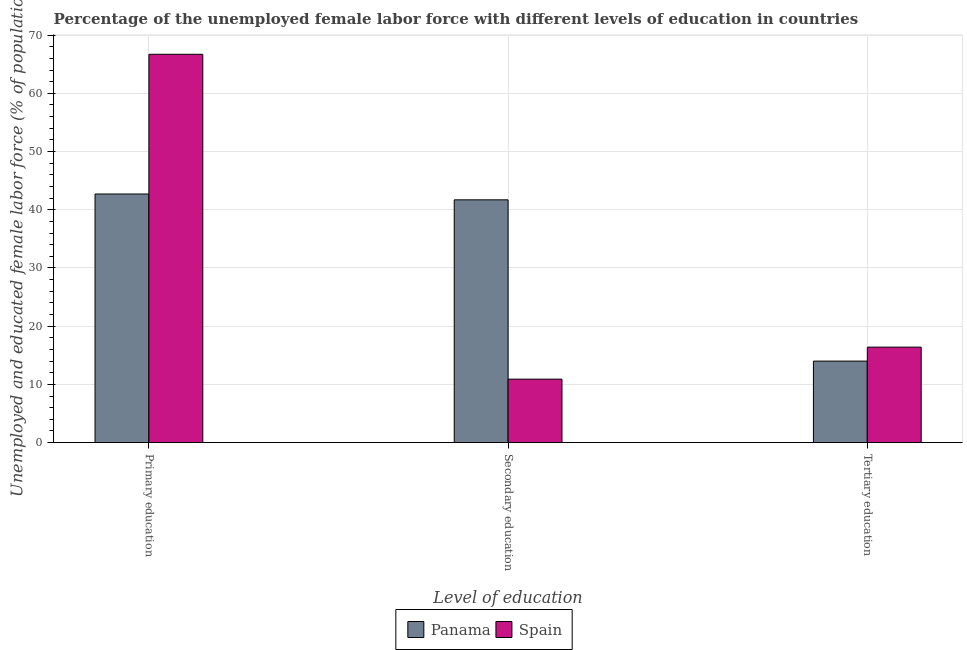How many groups of bars are there?
Provide a succinct answer. 3. Are the number of bars per tick equal to the number of legend labels?
Keep it short and to the point. Yes. Are the number of bars on each tick of the X-axis equal?
Provide a short and direct response. Yes. How many bars are there on the 3rd tick from the left?
Your answer should be compact. 2. How many bars are there on the 3rd tick from the right?
Ensure brevity in your answer.  2. What is the label of the 3rd group of bars from the left?
Ensure brevity in your answer.  Tertiary education. What is the percentage of female labor force who received secondary education in Spain?
Make the answer very short. 10.9. Across all countries, what is the maximum percentage of female labor force who received primary education?
Give a very brief answer. 66.7. In which country was the percentage of female labor force who received secondary education maximum?
Give a very brief answer. Panama. In which country was the percentage of female labor force who received secondary education minimum?
Your response must be concise. Spain. What is the total percentage of female labor force who received primary education in the graph?
Your answer should be compact. 109.4. What is the difference between the percentage of female labor force who received tertiary education in Spain and that in Panama?
Keep it short and to the point. 2.4. What is the difference between the percentage of female labor force who received secondary education in Panama and the percentage of female labor force who received tertiary education in Spain?
Provide a short and direct response. 25.3. What is the average percentage of female labor force who received primary education per country?
Keep it short and to the point. 54.7. What is the difference between the percentage of female labor force who received secondary education and percentage of female labor force who received primary education in Spain?
Your answer should be very brief. -55.8. What is the ratio of the percentage of female labor force who received tertiary education in Panama to that in Spain?
Your answer should be very brief. 0.85. Is the percentage of female labor force who received primary education in Spain less than that in Panama?
Provide a succinct answer. No. What is the difference between the highest and the second highest percentage of female labor force who received secondary education?
Provide a short and direct response. 30.8. What is the difference between the highest and the lowest percentage of female labor force who received tertiary education?
Ensure brevity in your answer.  2.4. What does the 1st bar from the right in Tertiary education represents?
Make the answer very short. Spain. How many bars are there?
Give a very brief answer. 6. How many countries are there in the graph?
Offer a very short reply. 2. Are the values on the major ticks of Y-axis written in scientific E-notation?
Offer a terse response. No. Does the graph contain any zero values?
Offer a terse response. No. Does the graph contain grids?
Provide a short and direct response. Yes. What is the title of the graph?
Offer a very short reply. Percentage of the unemployed female labor force with different levels of education in countries. What is the label or title of the X-axis?
Offer a very short reply. Level of education. What is the label or title of the Y-axis?
Offer a terse response. Unemployed and educated female labor force (% of population). What is the Unemployed and educated female labor force (% of population) of Panama in Primary education?
Offer a terse response. 42.7. What is the Unemployed and educated female labor force (% of population) of Spain in Primary education?
Your answer should be very brief. 66.7. What is the Unemployed and educated female labor force (% of population) of Panama in Secondary education?
Provide a succinct answer. 41.7. What is the Unemployed and educated female labor force (% of population) in Spain in Secondary education?
Offer a terse response. 10.9. What is the Unemployed and educated female labor force (% of population) of Spain in Tertiary education?
Make the answer very short. 16.4. Across all Level of education, what is the maximum Unemployed and educated female labor force (% of population) in Panama?
Give a very brief answer. 42.7. Across all Level of education, what is the maximum Unemployed and educated female labor force (% of population) in Spain?
Your answer should be compact. 66.7. Across all Level of education, what is the minimum Unemployed and educated female labor force (% of population) of Panama?
Offer a terse response. 14. Across all Level of education, what is the minimum Unemployed and educated female labor force (% of population) of Spain?
Your response must be concise. 10.9. What is the total Unemployed and educated female labor force (% of population) in Panama in the graph?
Make the answer very short. 98.4. What is the total Unemployed and educated female labor force (% of population) in Spain in the graph?
Keep it short and to the point. 94. What is the difference between the Unemployed and educated female labor force (% of population) of Spain in Primary education and that in Secondary education?
Provide a short and direct response. 55.8. What is the difference between the Unemployed and educated female labor force (% of population) in Panama in Primary education and that in Tertiary education?
Offer a terse response. 28.7. What is the difference between the Unemployed and educated female labor force (% of population) of Spain in Primary education and that in Tertiary education?
Provide a short and direct response. 50.3. What is the difference between the Unemployed and educated female labor force (% of population) in Panama in Secondary education and that in Tertiary education?
Provide a succinct answer. 27.7. What is the difference between the Unemployed and educated female labor force (% of population) of Spain in Secondary education and that in Tertiary education?
Keep it short and to the point. -5.5. What is the difference between the Unemployed and educated female labor force (% of population) of Panama in Primary education and the Unemployed and educated female labor force (% of population) of Spain in Secondary education?
Make the answer very short. 31.8. What is the difference between the Unemployed and educated female labor force (% of population) of Panama in Primary education and the Unemployed and educated female labor force (% of population) of Spain in Tertiary education?
Keep it short and to the point. 26.3. What is the difference between the Unemployed and educated female labor force (% of population) of Panama in Secondary education and the Unemployed and educated female labor force (% of population) of Spain in Tertiary education?
Provide a succinct answer. 25.3. What is the average Unemployed and educated female labor force (% of population) in Panama per Level of education?
Offer a very short reply. 32.8. What is the average Unemployed and educated female labor force (% of population) of Spain per Level of education?
Your answer should be very brief. 31.33. What is the difference between the Unemployed and educated female labor force (% of population) of Panama and Unemployed and educated female labor force (% of population) of Spain in Secondary education?
Keep it short and to the point. 30.8. What is the ratio of the Unemployed and educated female labor force (% of population) in Spain in Primary education to that in Secondary education?
Provide a succinct answer. 6.12. What is the ratio of the Unemployed and educated female labor force (% of population) of Panama in Primary education to that in Tertiary education?
Your answer should be very brief. 3.05. What is the ratio of the Unemployed and educated female labor force (% of population) in Spain in Primary education to that in Tertiary education?
Your response must be concise. 4.07. What is the ratio of the Unemployed and educated female labor force (% of population) of Panama in Secondary education to that in Tertiary education?
Ensure brevity in your answer.  2.98. What is the ratio of the Unemployed and educated female labor force (% of population) in Spain in Secondary education to that in Tertiary education?
Provide a succinct answer. 0.66. What is the difference between the highest and the second highest Unemployed and educated female labor force (% of population) in Panama?
Ensure brevity in your answer.  1. What is the difference between the highest and the second highest Unemployed and educated female labor force (% of population) in Spain?
Offer a very short reply. 50.3. What is the difference between the highest and the lowest Unemployed and educated female labor force (% of population) in Panama?
Your response must be concise. 28.7. What is the difference between the highest and the lowest Unemployed and educated female labor force (% of population) in Spain?
Provide a succinct answer. 55.8. 